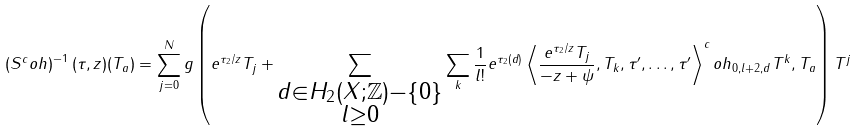Convert formula to latex. <formula><loc_0><loc_0><loc_500><loc_500>\left ( S ^ { c } o h \right ) ^ { - 1 } ( \tau , z ) ( T _ { a } ) = \sum _ { j = 0 } ^ { N } g \left ( e ^ { \tau _ { 2 } / z } T _ { j } + \sum _ { \substack { d \in H _ { 2 } ( X ; \mathbb { Z } ) - \{ 0 \} \\ l \geq 0 } } \sum _ { k } \frac { 1 } { l ! } e ^ { \tau _ { 2 } ( d ) } \left \langle \frac { e ^ { \tau _ { 2 } / z } T _ { j } } { - z + \psi } , T _ { k } , \tau ^ { \prime } , \dots , \tau ^ { \prime } \right \rangle ^ { c } o h _ { 0 , l + 2 , d } T ^ { k } , T _ { a } \right ) T ^ { j }</formula> 